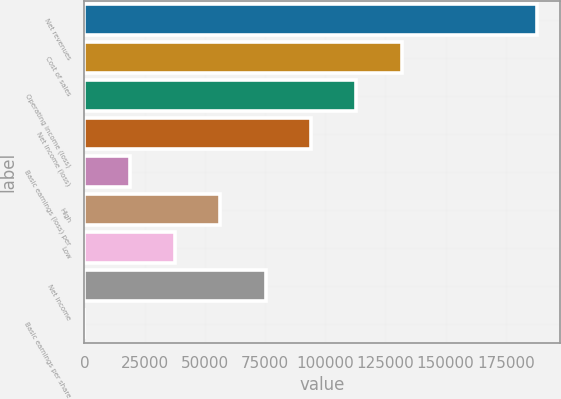<chart> <loc_0><loc_0><loc_500><loc_500><bar_chart><fcel>Net revenues<fcel>Cost of sales<fcel>Operating income (loss)<fcel>Net income (loss)<fcel>Basic earnings (loss) per<fcel>High<fcel>Low<fcel>Net income<fcel>Basic earnings per share<nl><fcel>188125<fcel>131688<fcel>112875<fcel>94062.5<fcel>18812.5<fcel>56437.5<fcel>37625<fcel>75250<fcel>0.01<nl></chart> 